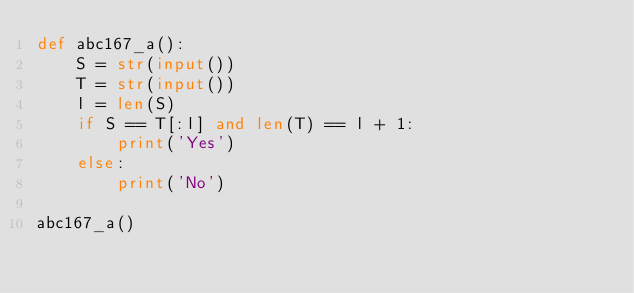Convert code to text. <code><loc_0><loc_0><loc_500><loc_500><_Python_>def abc167_a():
    S = str(input())
    T = str(input())
    l = len(S)
    if S == T[:l] and len(T) == l + 1:
        print('Yes')
    else:
        print('No')

abc167_a()</code> 